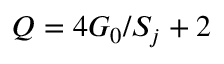Convert formula to latex. <formula><loc_0><loc_0><loc_500><loc_500>Q = 4 G _ { 0 } / S _ { j } + 2</formula> 